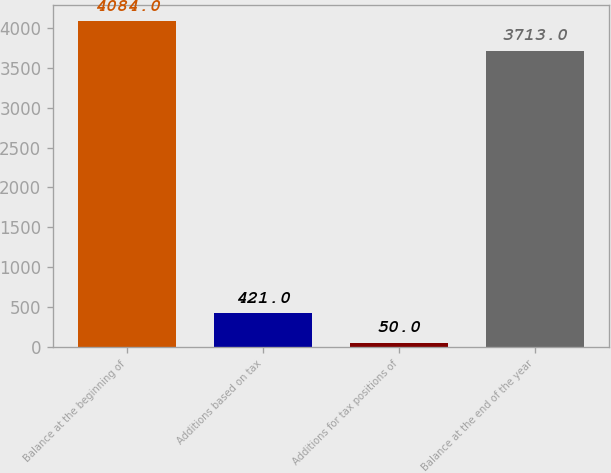<chart> <loc_0><loc_0><loc_500><loc_500><bar_chart><fcel>Balance at the beginning of<fcel>Additions based on tax<fcel>Additions for tax positions of<fcel>Balance at the end of the year<nl><fcel>4084<fcel>421<fcel>50<fcel>3713<nl></chart> 